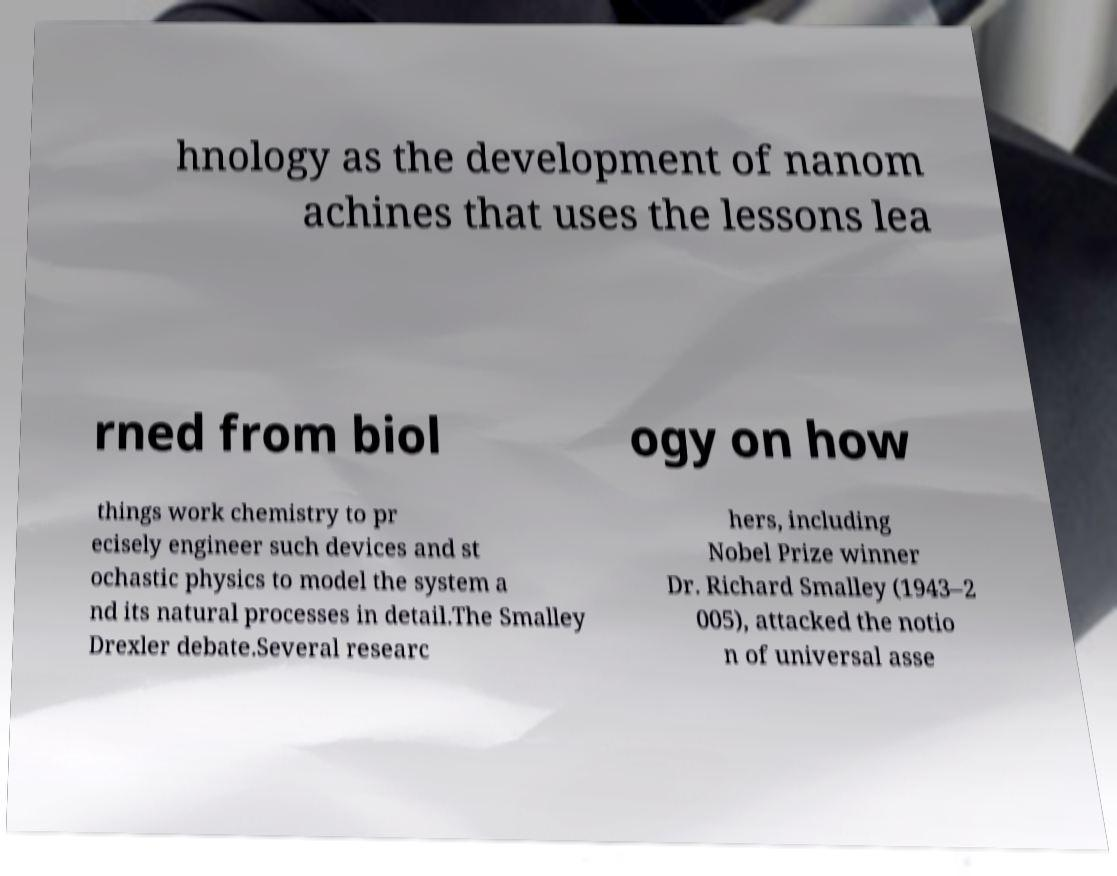Please read and relay the text visible in this image. What does it say? hnology as the development of nanom achines that uses the lessons lea rned from biol ogy on how things work chemistry to pr ecisely engineer such devices and st ochastic physics to model the system a nd its natural processes in detail.The Smalley Drexler debate.Several researc hers, including Nobel Prize winner Dr. Richard Smalley (1943–2 005), attacked the notio n of universal asse 